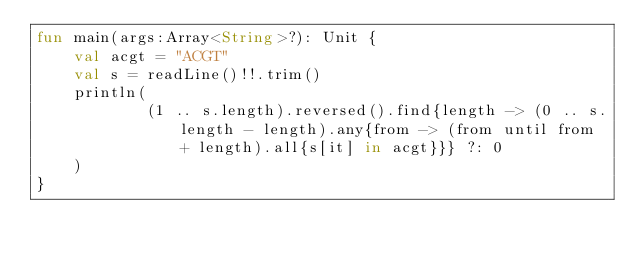<code> <loc_0><loc_0><loc_500><loc_500><_Kotlin_>fun main(args:Array<String>?): Unit {
    val acgt = "ACGT"
    val s = readLine()!!.trim()
    println(
            (1 .. s.length).reversed().find{length -> (0 .. s.length - length).any{from -> (from until from + length).all{s[it] in acgt}}} ?: 0
    )
}</code> 